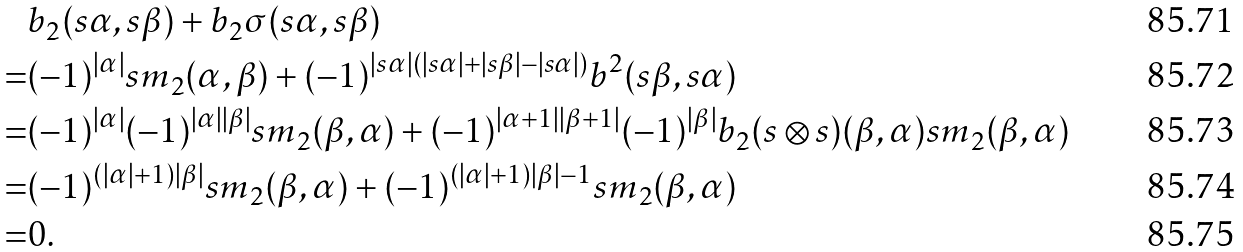<formula> <loc_0><loc_0><loc_500><loc_500>& b _ { 2 } ( s \alpha , s \beta ) + b _ { 2 } \sigma ( s \alpha , s \beta ) \\ = & ( - 1 ) ^ { | \alpha | } s m _ { 2 } ( \alpha , \beta ) + ( - 1 ) ^ { | s \alpha | ( | s \alpha | + | s \beta | - | s \alpha | ) } b ^ { 2 } ( s \beta , s \alpha ) \\ = & ( - 1 ) ^ { | \alpha | } ( - 1 ) ^ { | \alpha | | \beta | } s m _ { 2 } ( \beta , \alpha ) + ( - 1 ) ^ { | \alpha + 1 | | \beta + 1 | } ( - 1 ) ^ { | \beta | } b _ { 2 } ( s \otimes s ) ( \beta , \alpha ) s m _ { 2 } ( \beta , \alpha ) \\ = & ( - 1 ) ^ { ( | \alpha | + 1 ) | \beta | } s m _ { 2 } ( \beta , \alpha ) + ( - 1 ) ^ { ( | \alpha | + 1 ) | \beta | - 1 } s m _ { 2 } ( \beta , \alpha ) \\ = & 0 .</formula> 